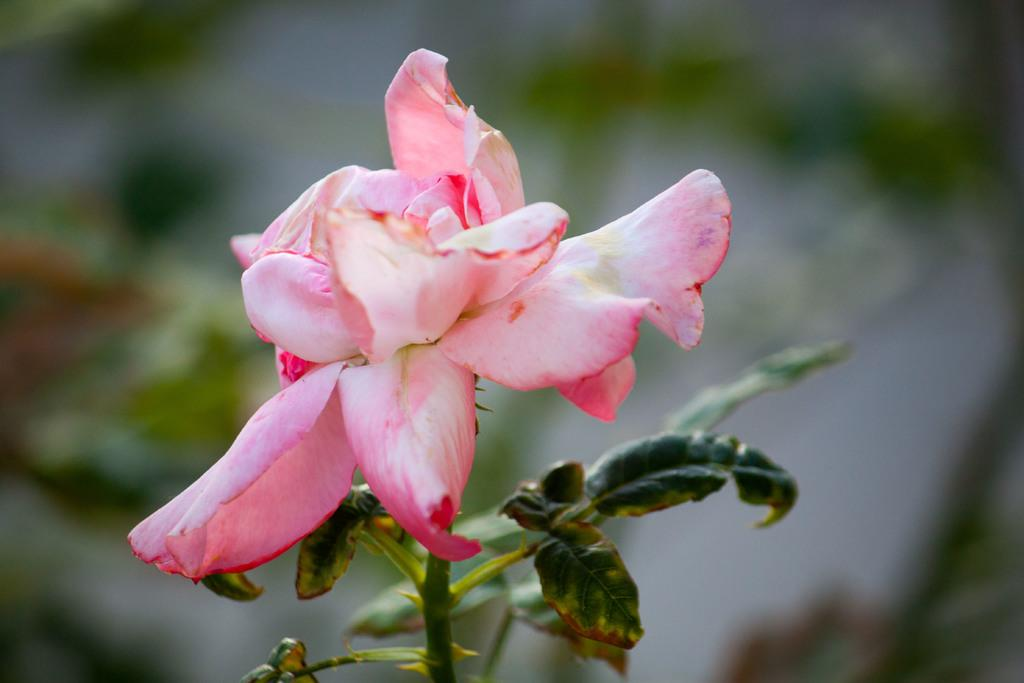What type of plant is visible in the image? There is a plant with a flower on its stem in the image. Can you describe the flower in the image? The flower is on the stem of the plant in the image. What type of shirt is the building wearing in the image? There is no building present in the image, and therefore no shirt or any clothing item can be associated with it. 